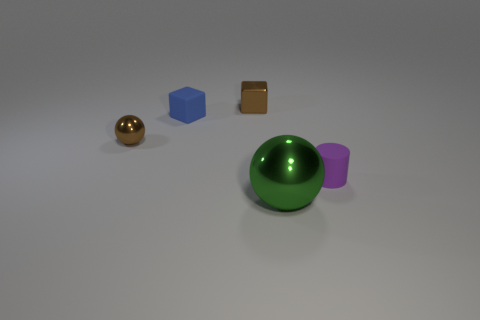Add 2 tiny gray spheres. How many objects exist? 7 Subtract all balls. How many objects are left? 3 Subtract 0 cyan spheres. How many objects are left? 5 Subtract all large green balls. Subtract all tiny blue matte blocks. How many objects are left? 3 Add 1 small purple cylinders. How many small purple cylinders are left? 2 Add 1 blue rubber cylinders. How many blue rubber cylinders exist? 1 